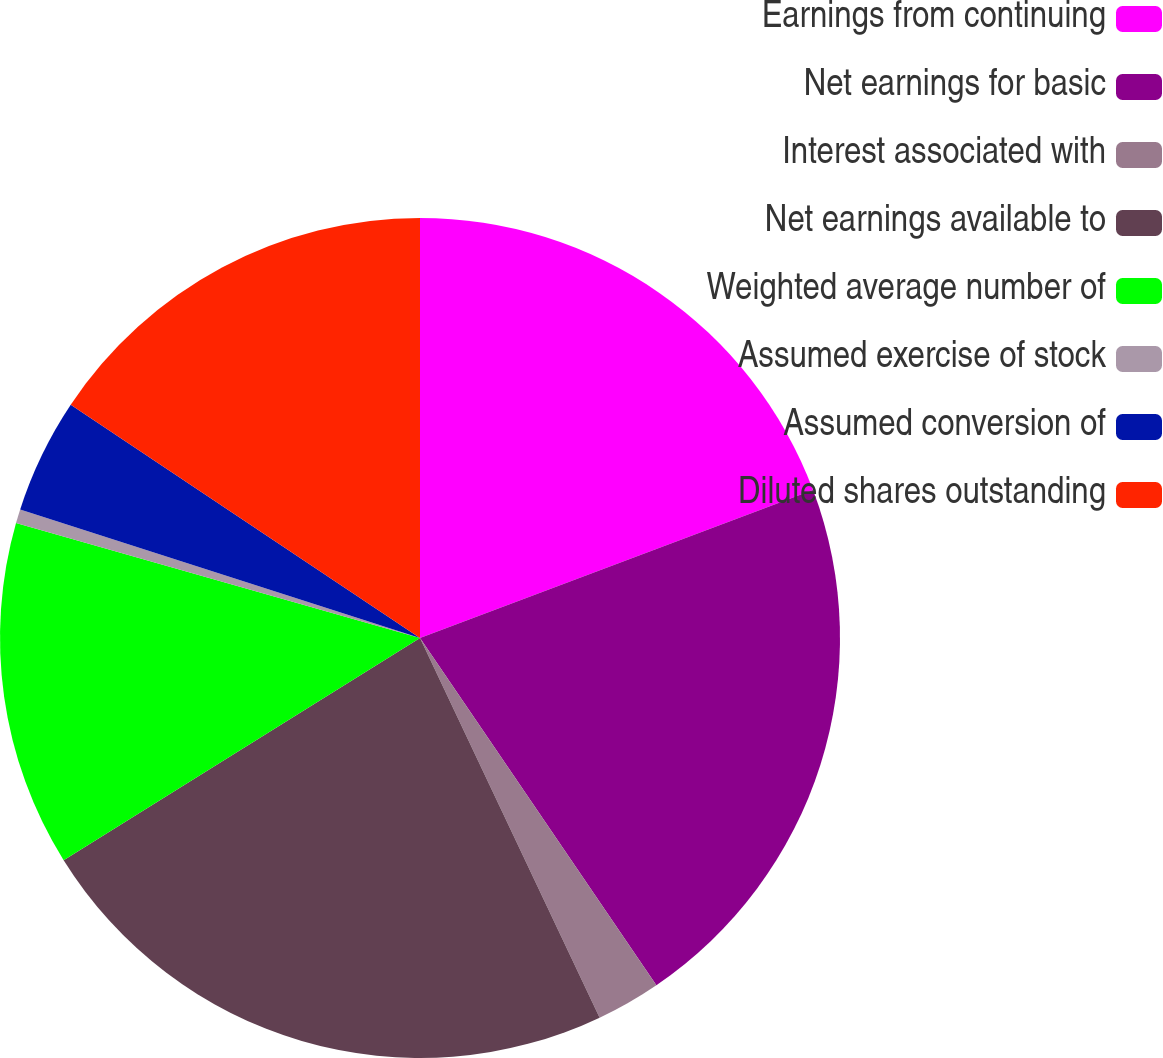Convert chart to OTSL. <chart><loc_0><loc_0><loc_500><loc_500><pie_chart><fcel>Earnings from continuing<fcel>Net earnings for basic<fcel>Interest associated with<fcel>Net earnings available to<fcel>Weighted average number of<fcel>Assumed exercise of stock<fcel>Assumed conversion of<fcel>Diluted shares outstanding<nl><fcel>19.27%<fcel>21.22%<fcel>2.48%<fcel>23.16%<fcel>13.29%<fcel>0.54%<fcel>4.42%<fcel>15.63%<nl></chart> 